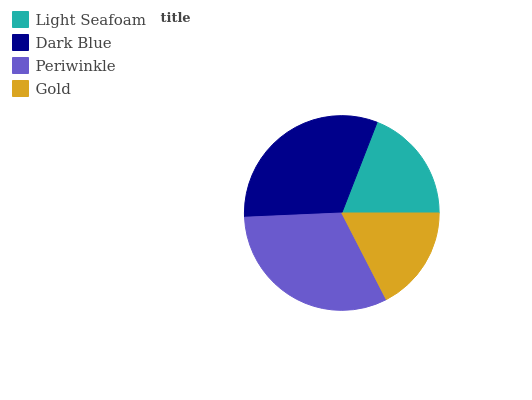Is Gold the minimum?
Answer yes or no. Yes. Is Periwinkle the maximum?
Answer yes or no. Yes. Is Dark Blue the minimum?
Answer yes or no. No. Is Dark Blue the maximum?
Answer yes or no. No. Is Dark Blue greater than Light Seafoam?
Answer yes or no. Yes. Is Light Seafoam less than Dark Blue?
Answer yes or no. Yes. Is Light Seafoam greater than Dark Blue?
Answer yes or no. No. Is Dark Blue less than Light Seafoam?
Answer yes or no. No. Is Dark Blue the high median?
Answer yes or no. Yes. Is Light Seafoam the low median?
Answer yes or no. Yes. Is Periwinkle the high median?
Answer yes or no. No. Is Dark Blue the low median?
Answer yes or no. No. 